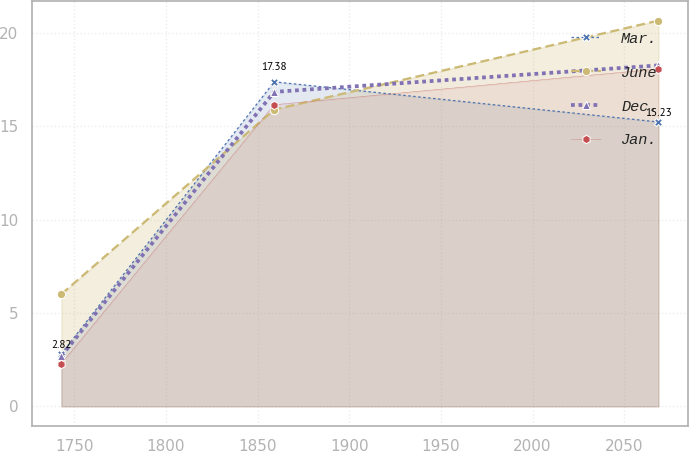<chart> <loc_0><loc_0><loc_500><loc_500><line_chart><ecel><fcel>Mar.<fcel>June<fcel>Dec.<fcel>Jan.<nl><fcel>1743.03<fcel>2.82<fcel>6.01<fcel>2.7<fcel>2.29<nl><fcel>1859.09<fcel>17.38<fcel>15.89<fcel>16.84<fcel>16.15<nl><fcel>2068.65<fcel>15.23<fcel>20.66<fcel>18.26<fcel>18.07<nl></chart> 